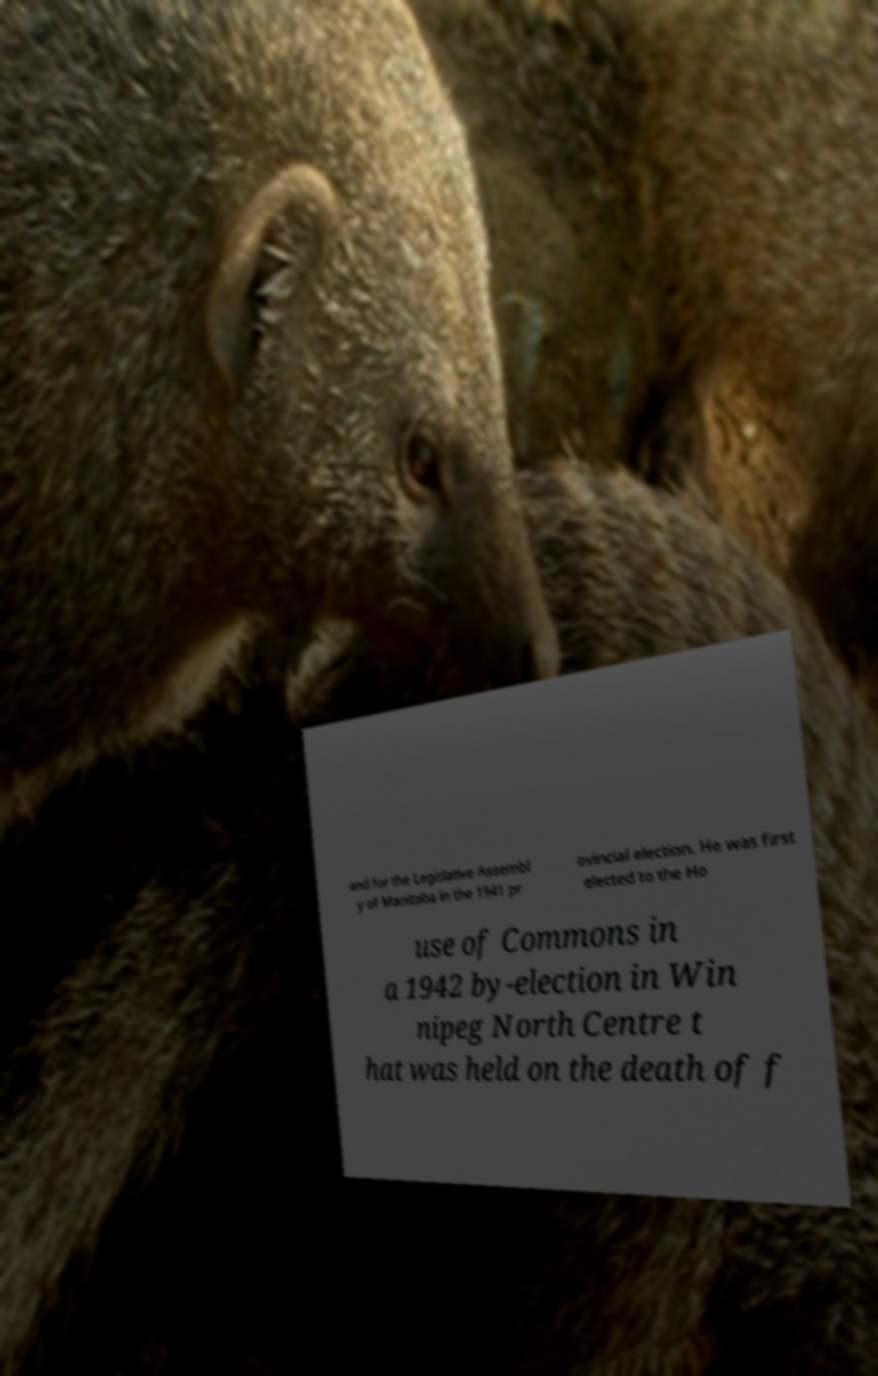I need the written content from this picture converted into text. Can you do that? and for the Legislative Assembl y of Manitoba in the 1941 pr ovincial election. He was first elected to the Ho use of Commons in a 1942 by-election in Win nipeg North Centre t hat was held on the death of f 